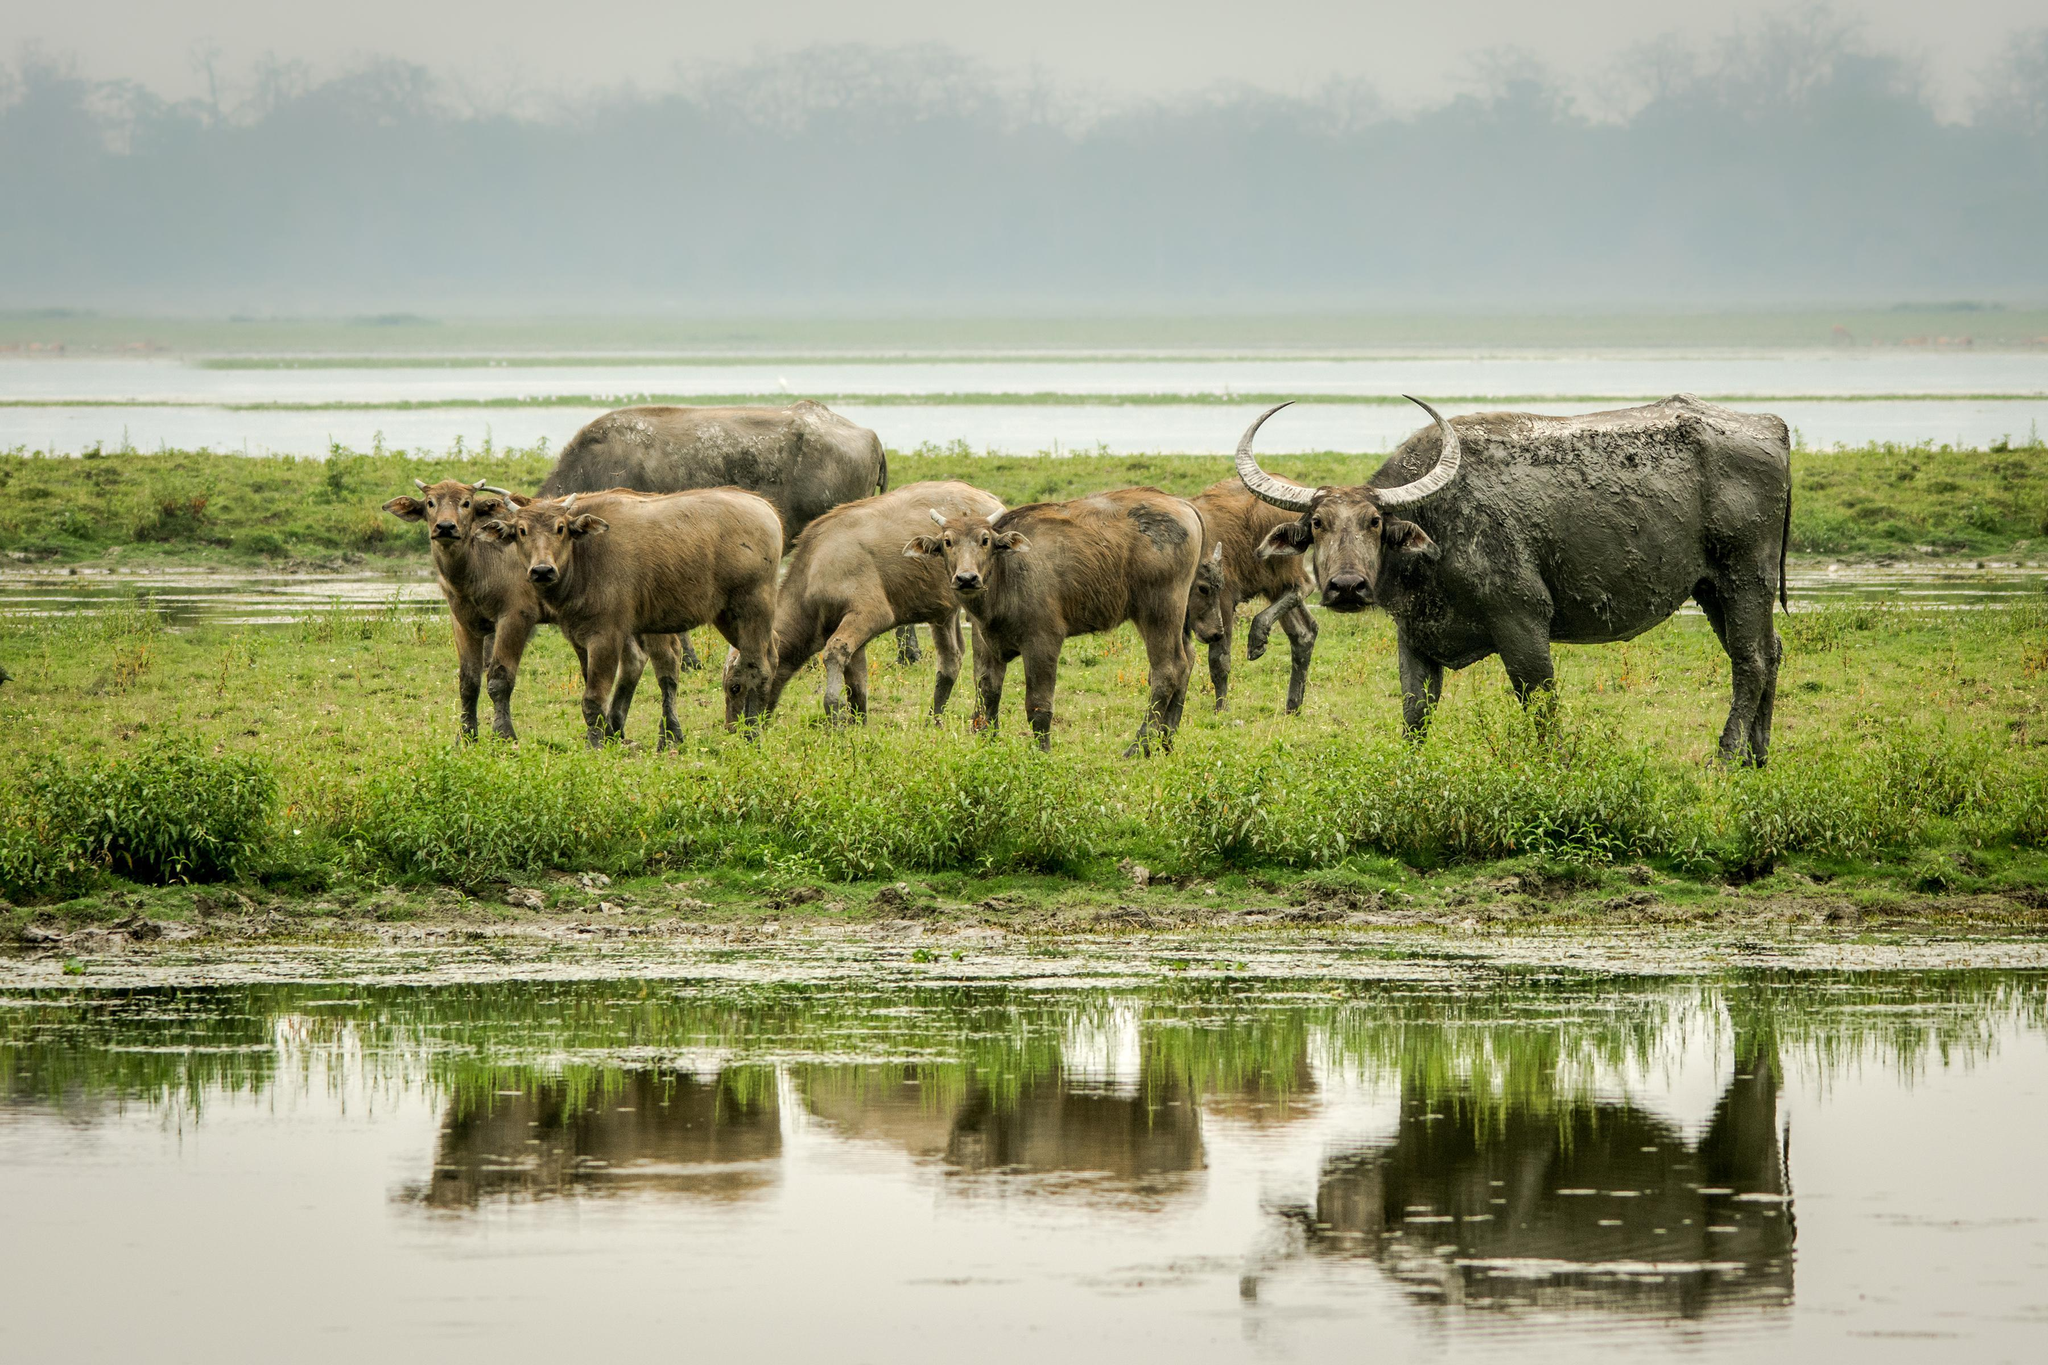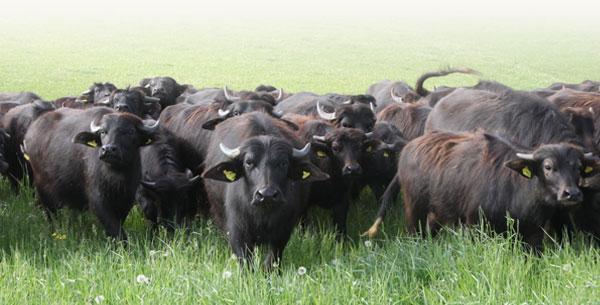The first image is the image on the left, the second image is the image on the right. Assess this claim about the two images: "An image shows water buffalo standing with a pool of water behind them, but not in front of them.". Correct or not? Answer yes or no. No. 